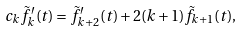<formula> <loc_0><loc_0><loc_500><loc_500>c _ { k } { \tilde { f } _ { k } } ^ { \prime } ( t ) = { \tilde { f } _ { k + 2 } } ^ { \prime } ( t ) + 2 ( k + 1 ) \tilde { f } _ { k + 1 } ( t ) ,</formula> 